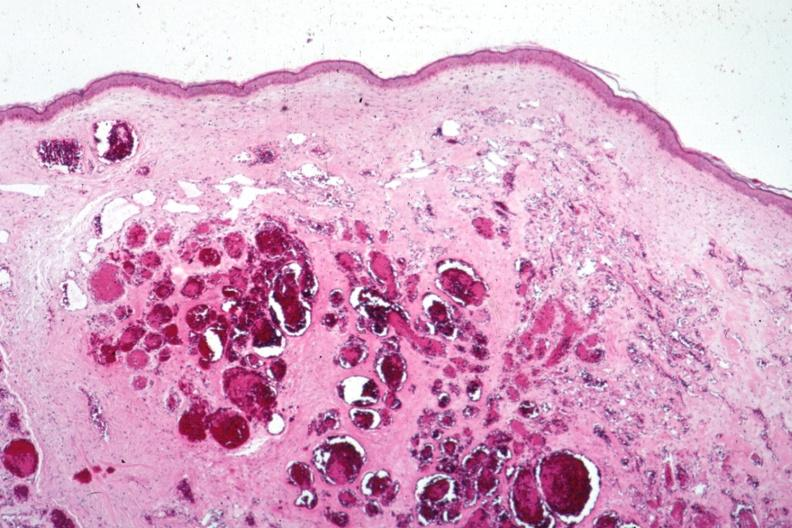where is this?
Answer the question using a single word or phrase. Skin 